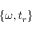<formula> <loc_0><loc_0><loc_500><loc_500>\{ \omega , t _ { r } \}</formula> 